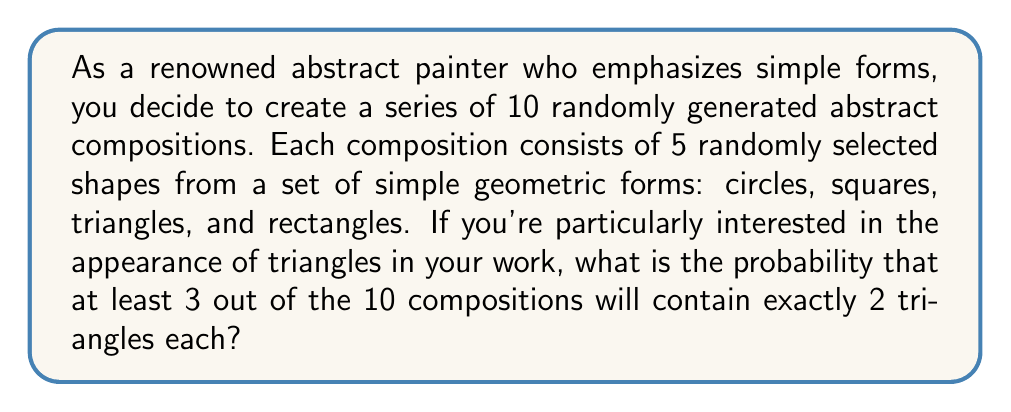Give your solution to this math problem. Let's approach this problem step by step:

1) First, we need to calculate the probability of a single composition containing exactly 2 triangles.

   - Each composition has 5 shapes.
   - The probability of selecting a triangle for each shape is 1/4.
   - We can use the binomial probability formula:

   $$P(\text{exactly 2 triangles}) = \binom{5}{2} \left(\frac{1}{4}\right)^2 \left(\frac{3}{4}\right)^3$$

   $$= 10 \cdot \frac{1}{16} \cdot \frac{27}{64} = \frac{270}{1024} \approx 0.2637$$

2) Now, we need to calculate the probability of at least 3 out of 10 compositions having exactly 2 triangles.

   - This is equivalent to 1 minus the probability of 0, 1, or 2 compositions having exactly 2 triangles.
   - We can use the binomial probability formula again:

   $$P(\text{at least 3}) = 1 - [P(0) + P(1) + P(2)]$$

   $$= 1 - \left[\binom{10}{0}p^0(1-p)^{10} + \binom{10}{1}p^1(1-p)^9 + \binom{10}{2}p^2(1-p)^8\right]$$

   Where $p = \frac{270}{1024}$

3) Calculating each term:

   $$P(0) = \binom{10}{0}\left(\frac{270}{1024}\right)^0\left(\frac{754}{1024}\right)^{10} \approx 0.0778$$
   
   $$P(1) = \binom{10}{1}\left(\frac{270}{1024}\right)^1\left(\frac{754}{1024}\right)^9 \approx 0.2775$$
   
   $$P(2) = \binom{10}{2}\left(\frac{270}{1024}\right)^2\left(\frac{754}{1024}\right)^8 \approx 0.4443$$

4) Therefore, the final probability is:

   $$P(\text{at least 3}) = 1 - (0.0778 + 0.2775 + 0.4443) = 0.2004$$
Answer: The probability that at least 3 out of 10 compositions will contain exactly 2 triangles each is approximately 0.2004 or 20.04%. 